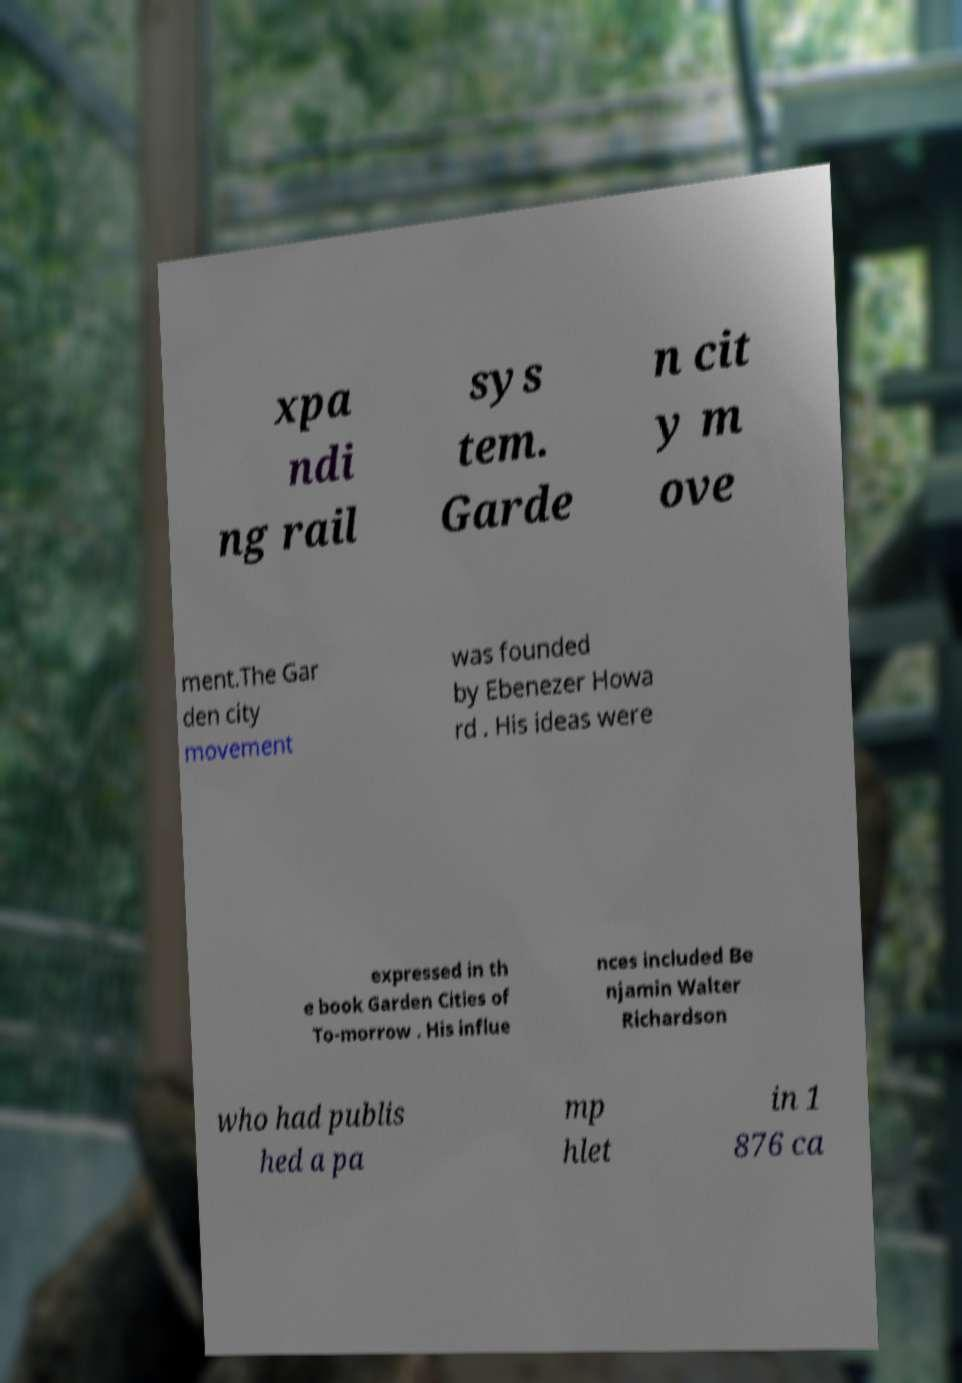Please identify and transcribe the text found in this image. xpa ndi ng rail sys tem. Garde n cit y m ove ment.The Gar den city movement was founded by Ebenezer Howa rd . His ideas were expressed in th e book Garden Cities of To-morrow . His influe nces included Be njamin Walter Richardson who had publis hed a pa mp hlet in 1 876 ca 